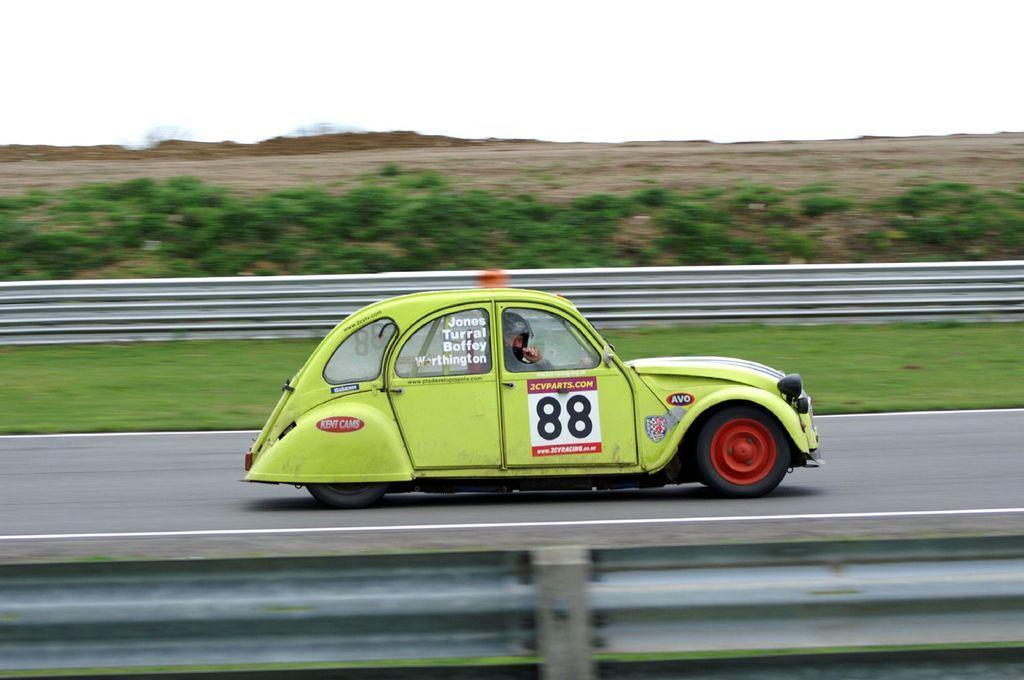Could you give a brief overview of what you see in this image? In the middle of the image, there is a light green color vehicle, on which there is a poster, on the road, on which there are two white color lines. On both sides of this road, there is a fence. In the background, there are plants on the ground and there is sky. 